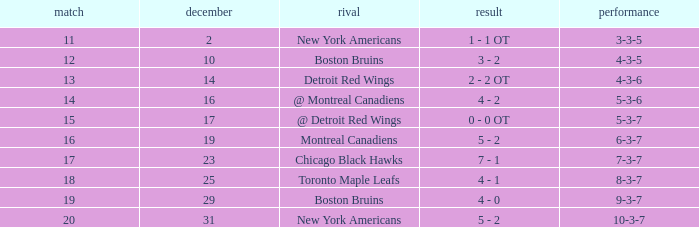Which December has a Record of 4-3-6? 14.0. 